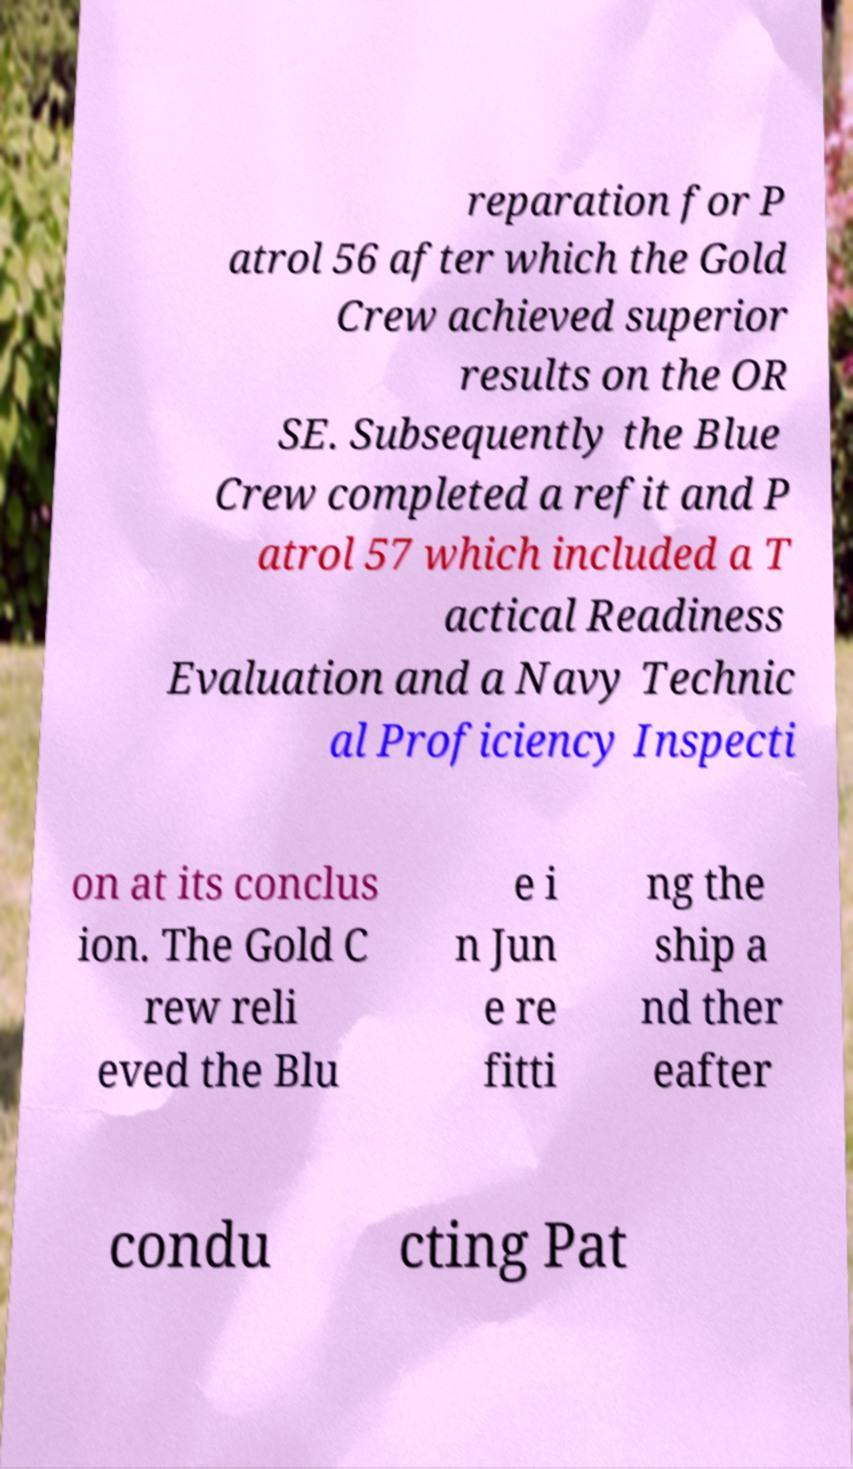Can you accurately transcribe the text from the provided image for me? reparation for P atrol 56 after which the Gold Crew achieved superior results on the OR SE. Subsequently the Blue Crew completed a refit and P atrol 57 which included a T actical Readiness Evaluation and a Navy Technic al Proficiency Inspecti on at its conclus ion. The Gold C rew reli eved the Blu e i n Jun e re fitti ng the ship a nd ther eafter condu cting Pat 